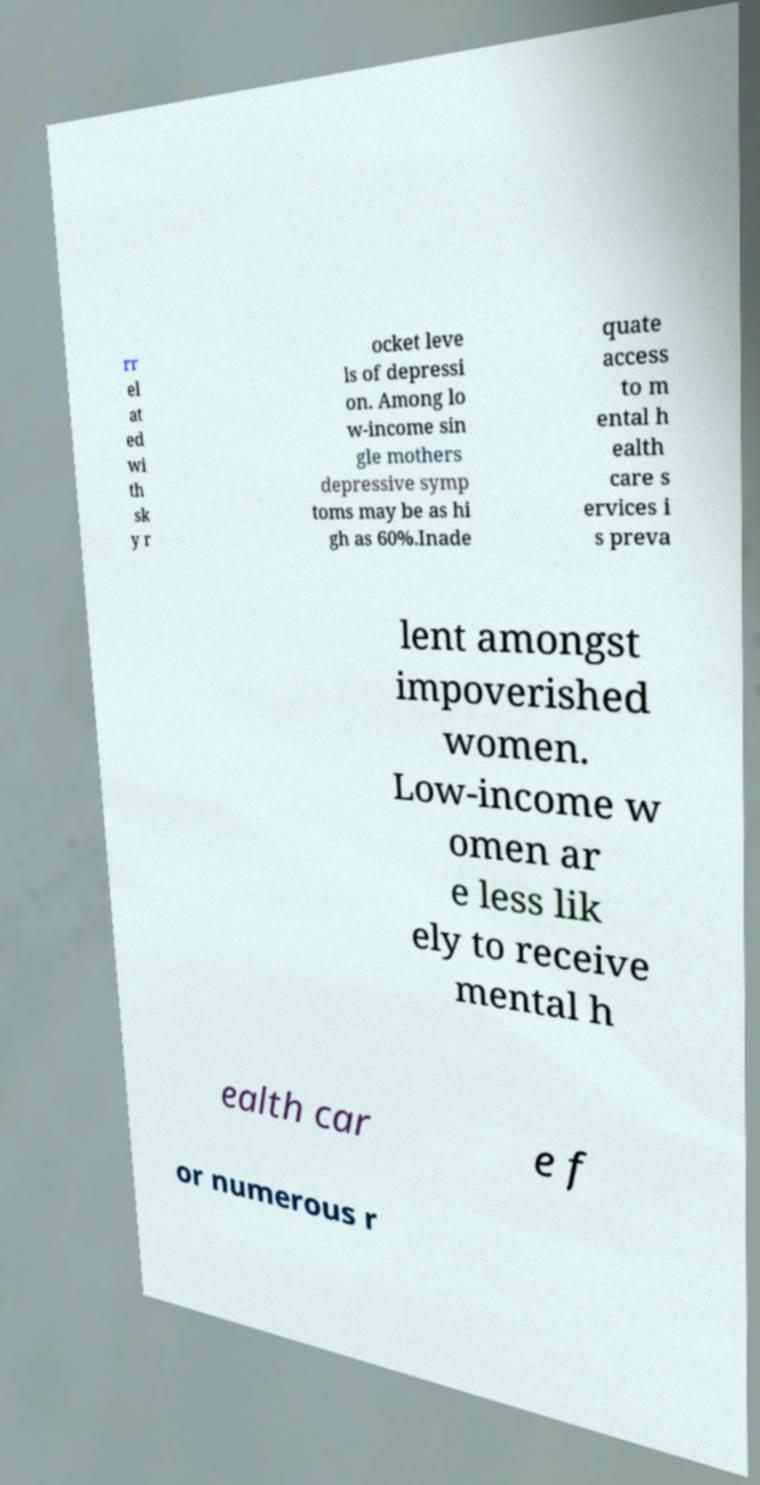Can you accurately transcribe the text from the provided image for me? rr el at ed wi th sk y r ocket leve ls of depressi on. Among lo w-income sin gle mothers depressive symp toms may be as hi gh as 60%.Inade quate access to m ental h ealth care s ervices i s preva lent amongst impoverished women. Low-income w omen ar e less lik ely to receive mental h ealth car e f or numerous r 